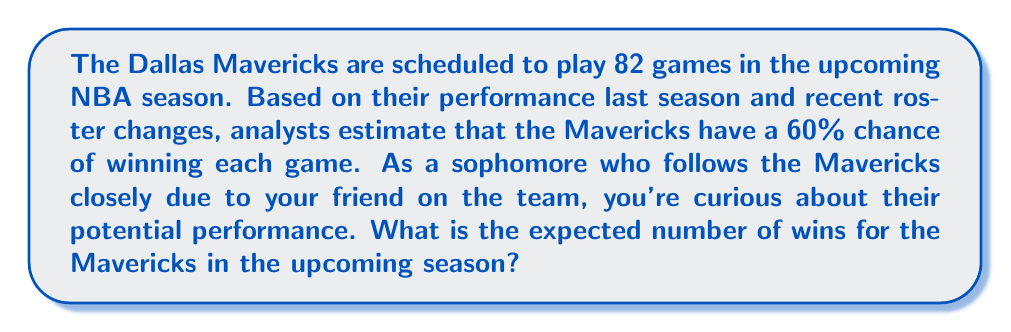Can you solve this math problem? Let's approach this step-by-step:

1) The expected value of a binary outcome (win or loss) is calculated by multiplying the probability of the event by the number of trials.

2) In this case:
   - Probability of winning each game: $p = 0.60$ (or 60%)
   - Number of games in the season: $n = 82$

3) The expected value formula for this scenario is:

   $$E(\text{wins}) = n \cdot p$$

4) Substituting our values:

   $$E(\text{wins}) = 82 \cdot 0.60$$

5) Calculating:

   $$E(\text{wins}) = 49.2$$

6) Since we can't have a fractional number of wins, we round to the nearest whole number.

Therefore, the expected number of wins for the Mavericks in the upcoming season is 49 games.
Answer: 49 wins 